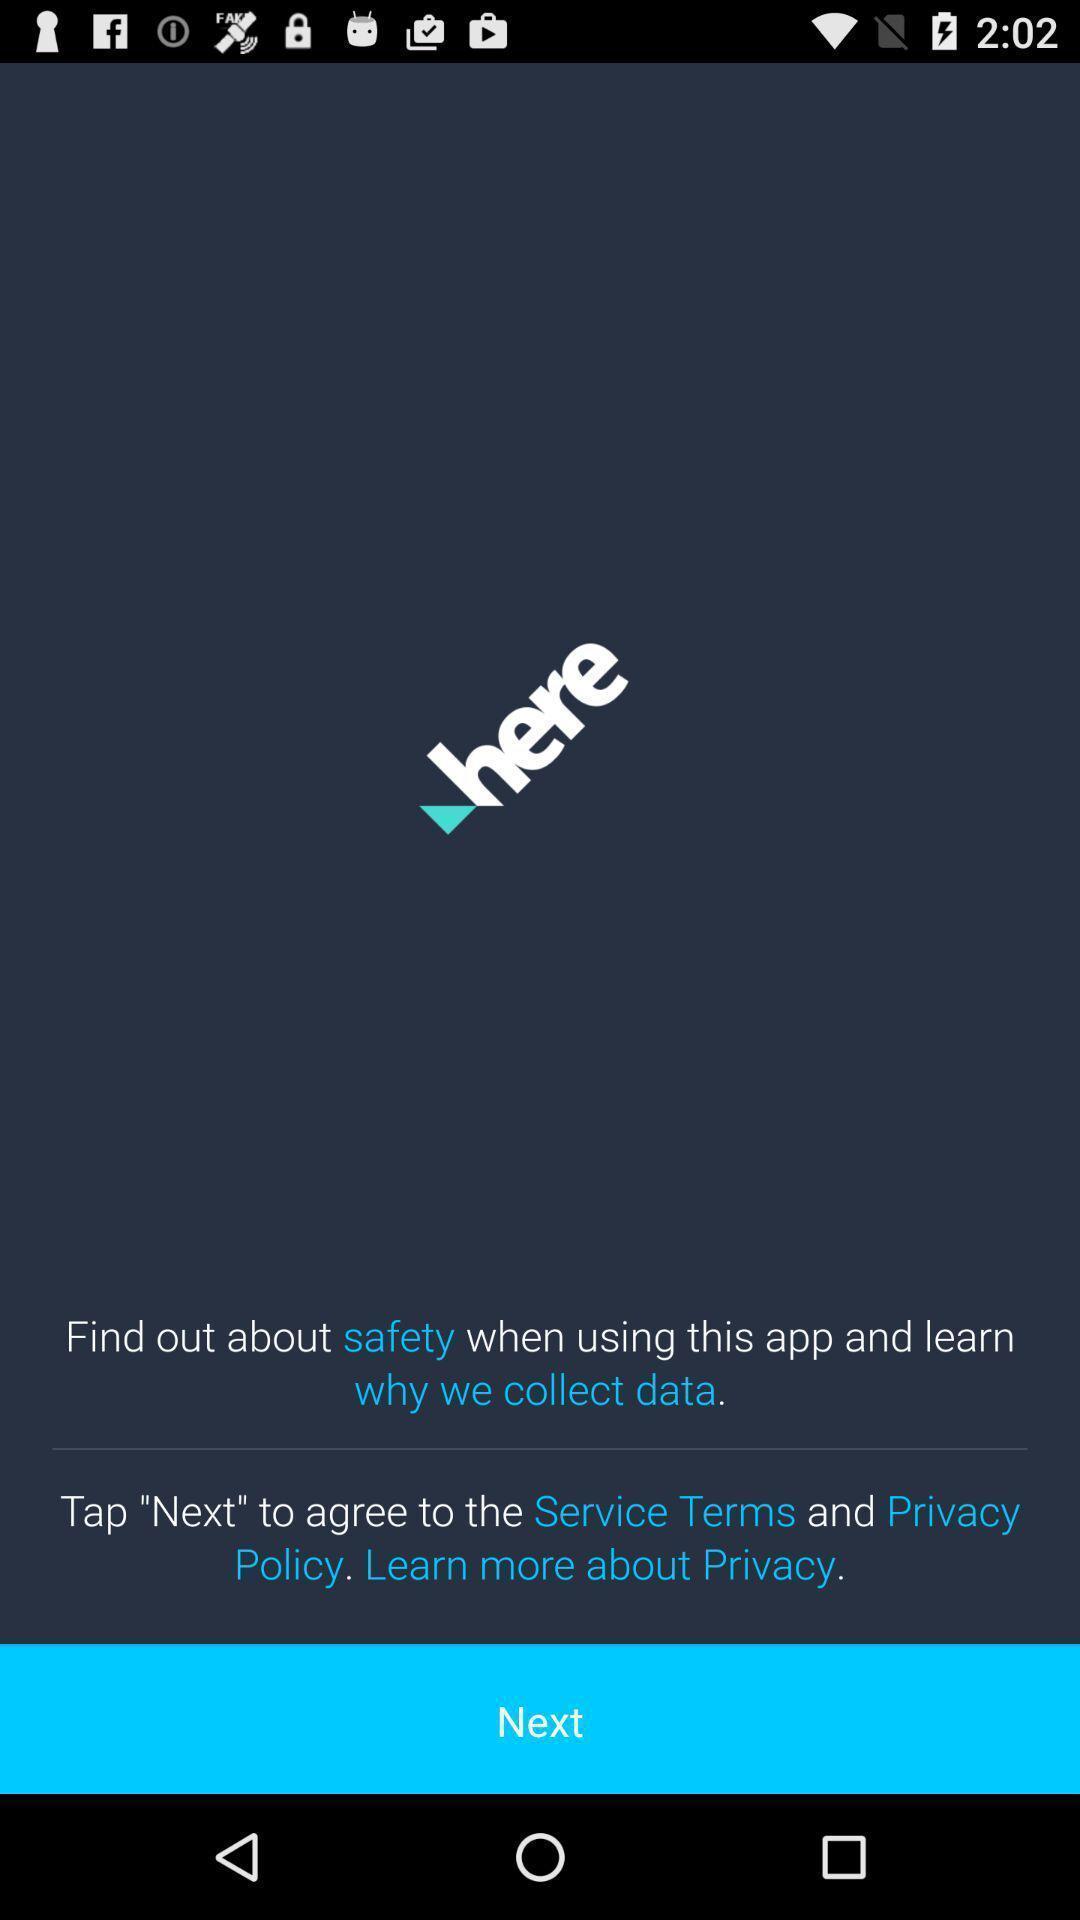What is the overall content of this screenshot? Screen shows next option in a travel app. 